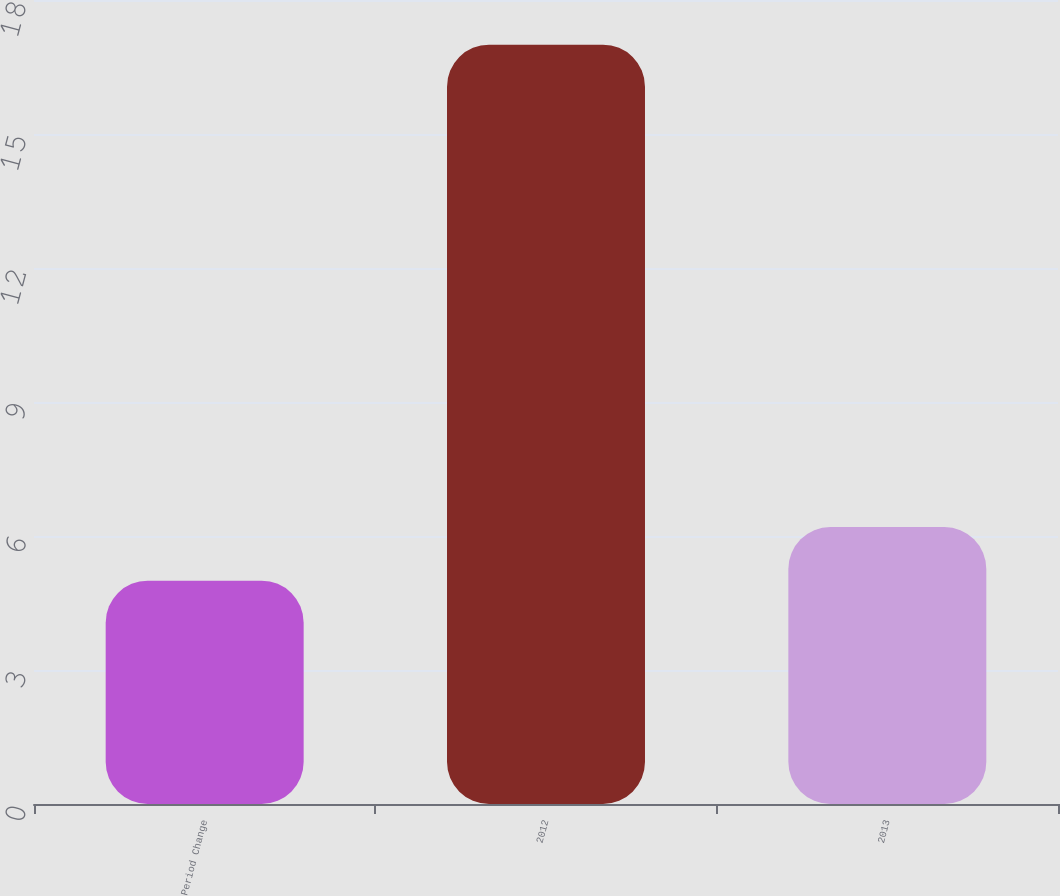Convert chart. <chart><loc_0><loc_0><loc_500><loc_500><bar_chart><fcel>Period Change<fcel>2012<fcel>2013<nl><fcel>5<fcel>17<fcel>6.2<nl></chart> 